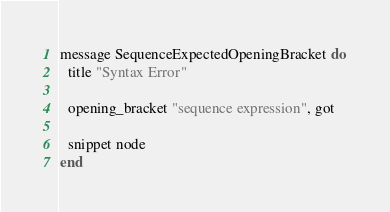Convert code to text. <code><loc_0><loc_0><loc_500><loc_500><_Crystal_>message SequenceExpectedOpeningBracket do
  title "Syntax Error"

  opening_bracket "sequence expression", got

  snippet node
end
</code> 